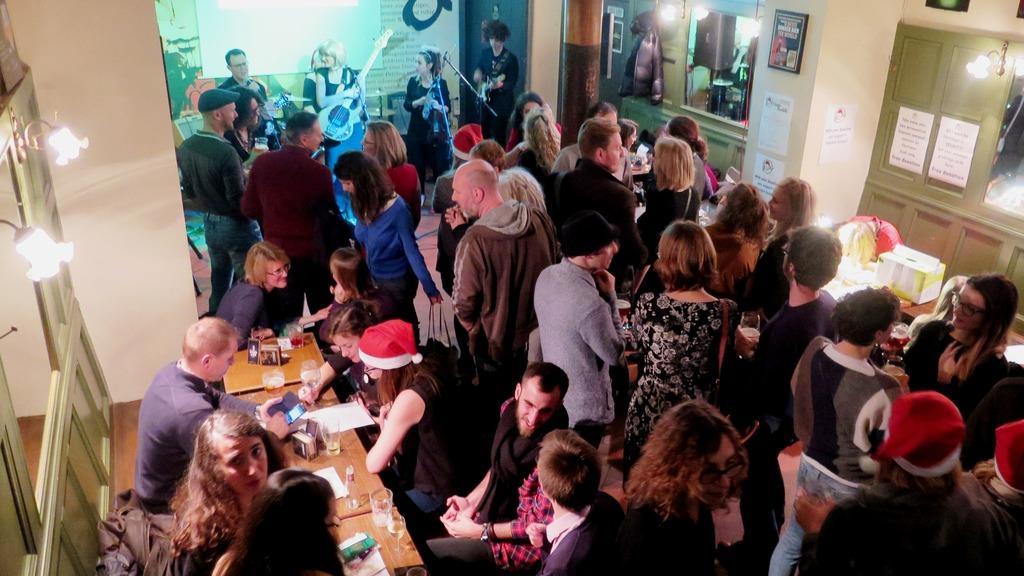Please provide a concise description of this image. In the picture we can see a group of people in the house and some people are sitting on the chairs near the table on it we can see some glasses of drinks, and a bottles and in the background we can see some people are giving a musical performance and to the walls we can see windows with lights to it. 